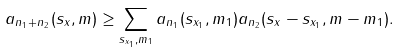Convert formula to latex. <formula><loc_0><loc_0><loc_500><loc_500>a _ { n _ { 1 } + n _ { 2 } } ( s _ { x } , m ) \geq \sum _ { s _ { x _ { 1 } } , m _ { 1 } } a _ { n _ { 1 } } ( s _ { x _ { 1 } } , m _ { 1 } ) a _ { n _ { 2 } } ( s _ { x } - s _ { x _ { 1 } } , m - m _ { 1 } ) .</formula> 